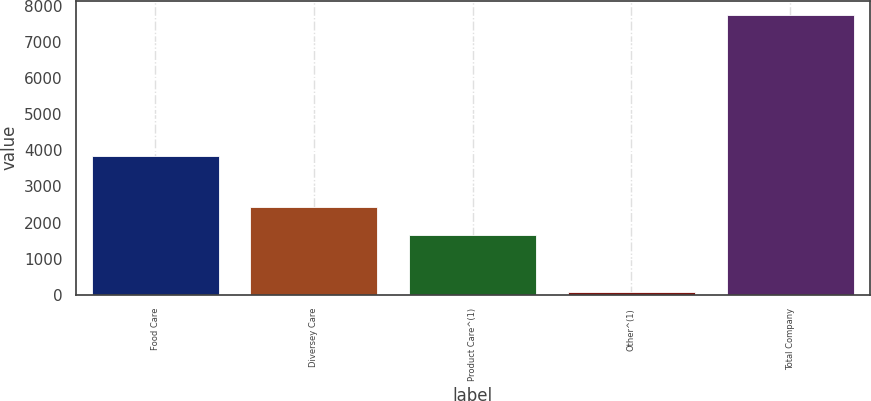Convert chart to OTSL. <chart><loc_0><loc_0><loc_500><loc_500><bar_chart><fcel>Food Care<fcel>Diversey Care<fcel>Product Care^(1)<fcel>Other^(1)<fcel>Total Company<nl><fcel>3835.3<fcel>2429.7<fcel>1662.6<fcel>79.5<fcel>7750.5<nl></chart> 